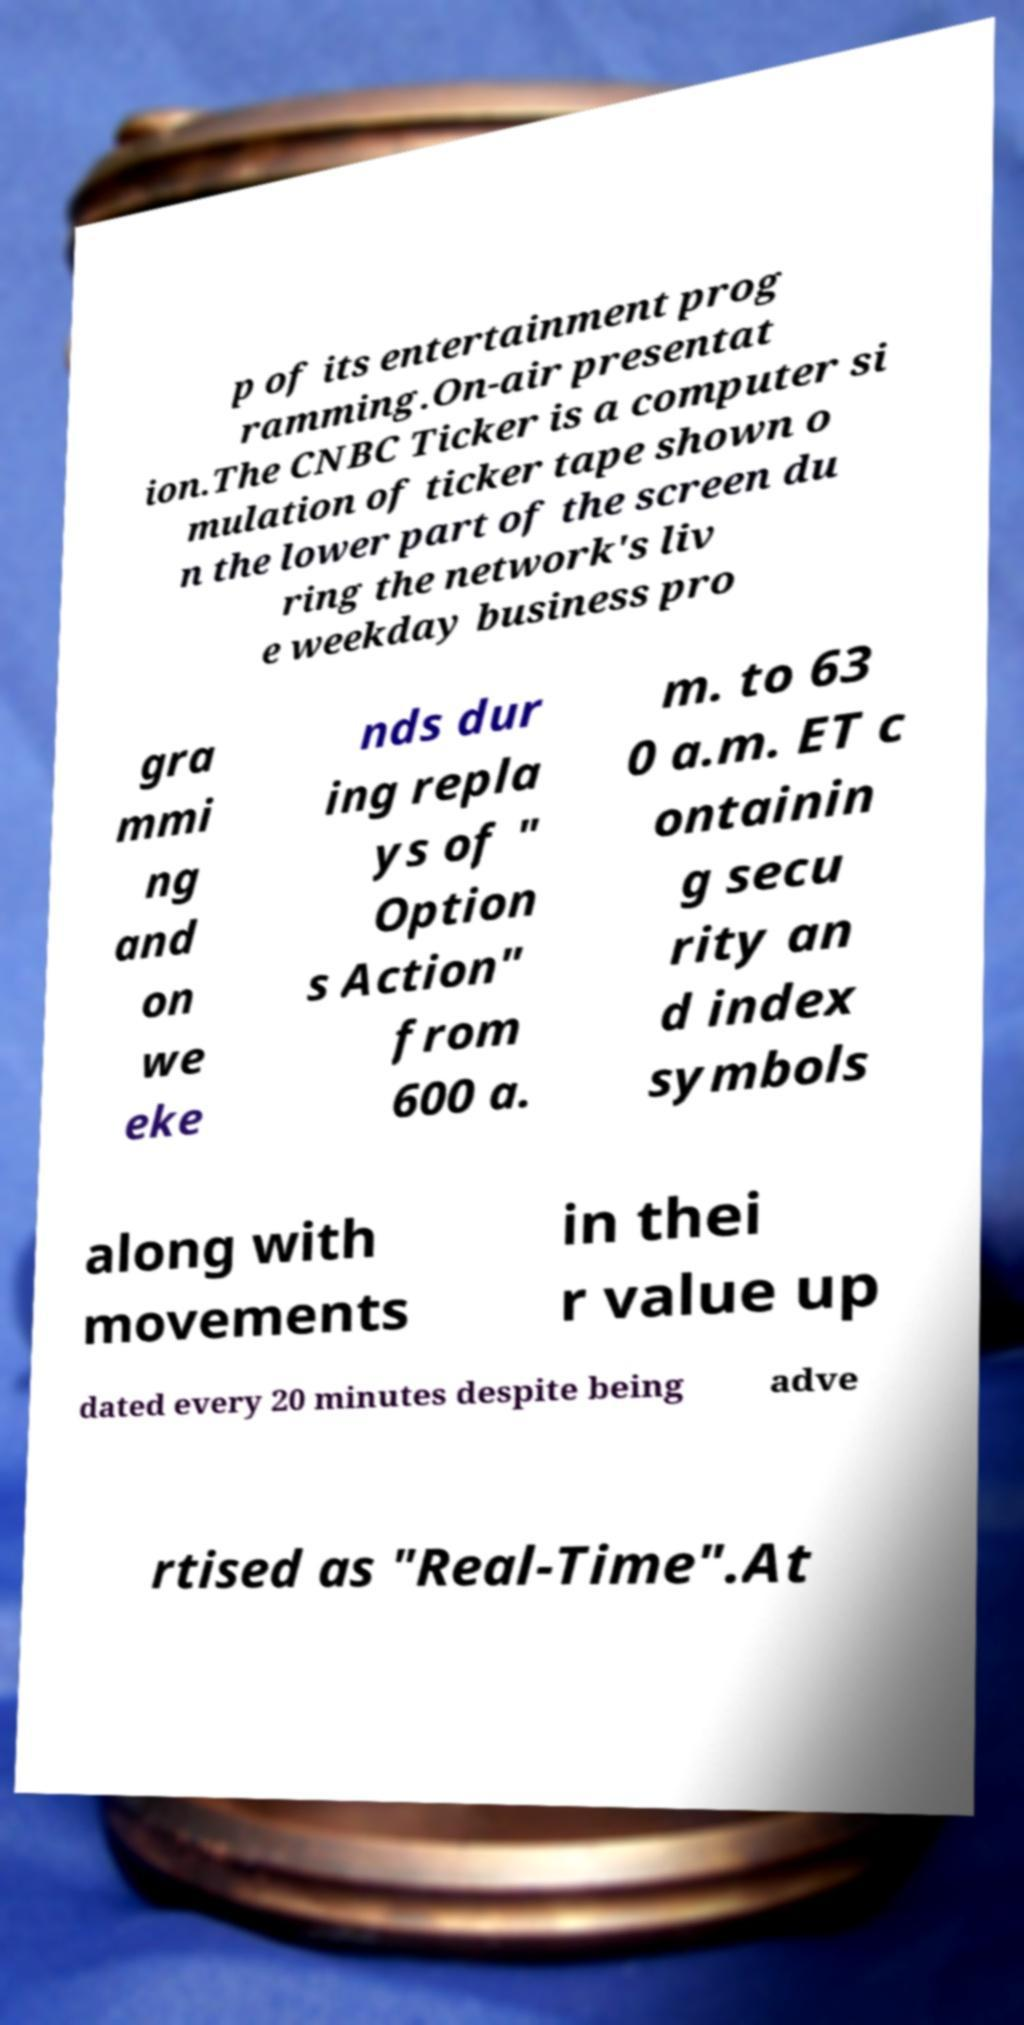Please read and relay the text visible in this image. What does it say? p of its entertainment prog ramming.On-air presentat ion.The CNBC Ticker is a computer si mulation of ticker tape shown o n the lower part of the screen du ring the network's liv e weekday business pro gra mmi ng and on we eke nds dur ing repla ys of " Option s Action" from 600 a. m. to 63 0 a.m. ET c ontainin g secu rity an d index symbols along with movements in thei r value up dated every 20 minutes despite being adve rtised as "Real-Time".At 